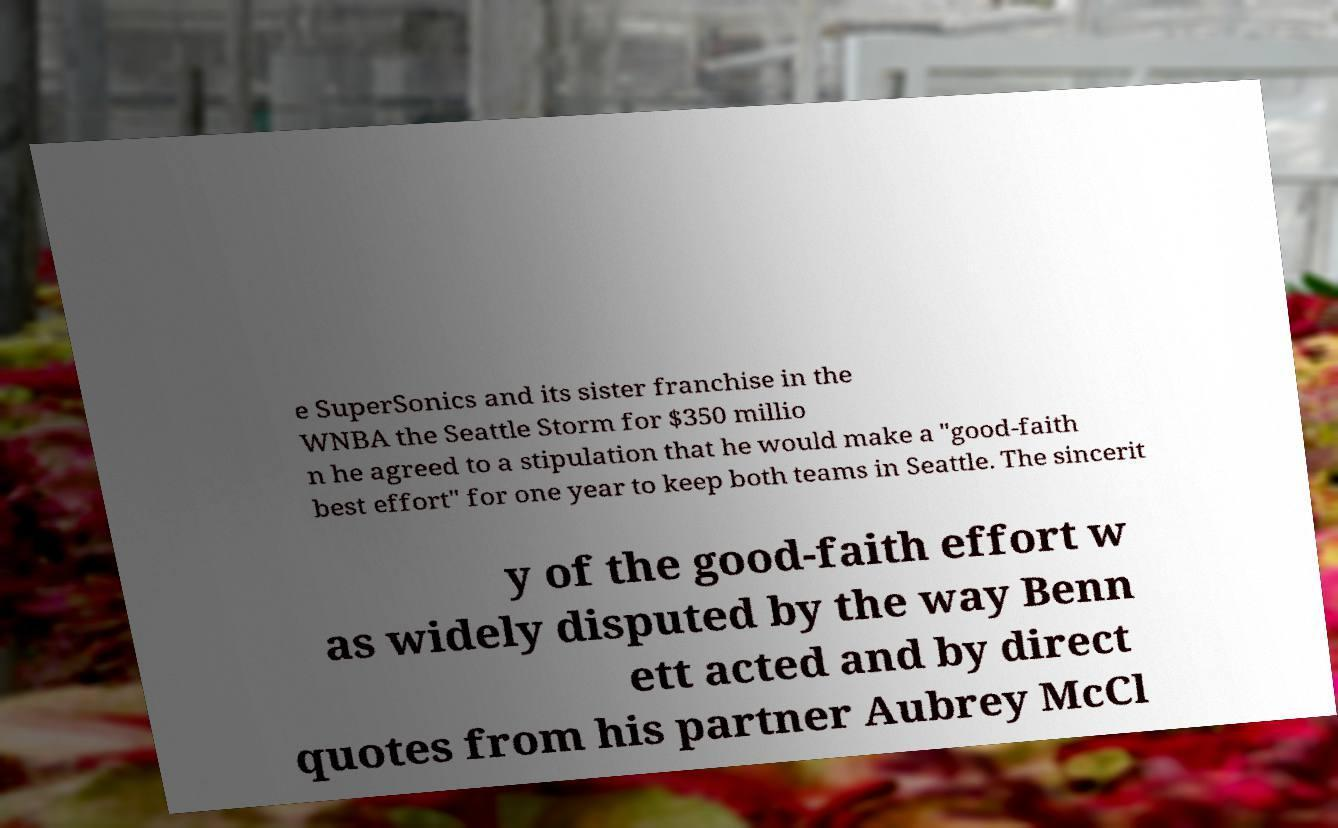Please identify and transcribe the text found in this image. e SuperSonics and its sister franchise in the WNBA the Seattle Storm for $350 millio n he agreed to a stipulation that he would make a "good-faith best effort" for one year to keep both teams in Seattle. The sincerit y of the good-faith effort w as widely disputed by the way Benn ett acted and by direct quotes from his partner Aubrey McCl 